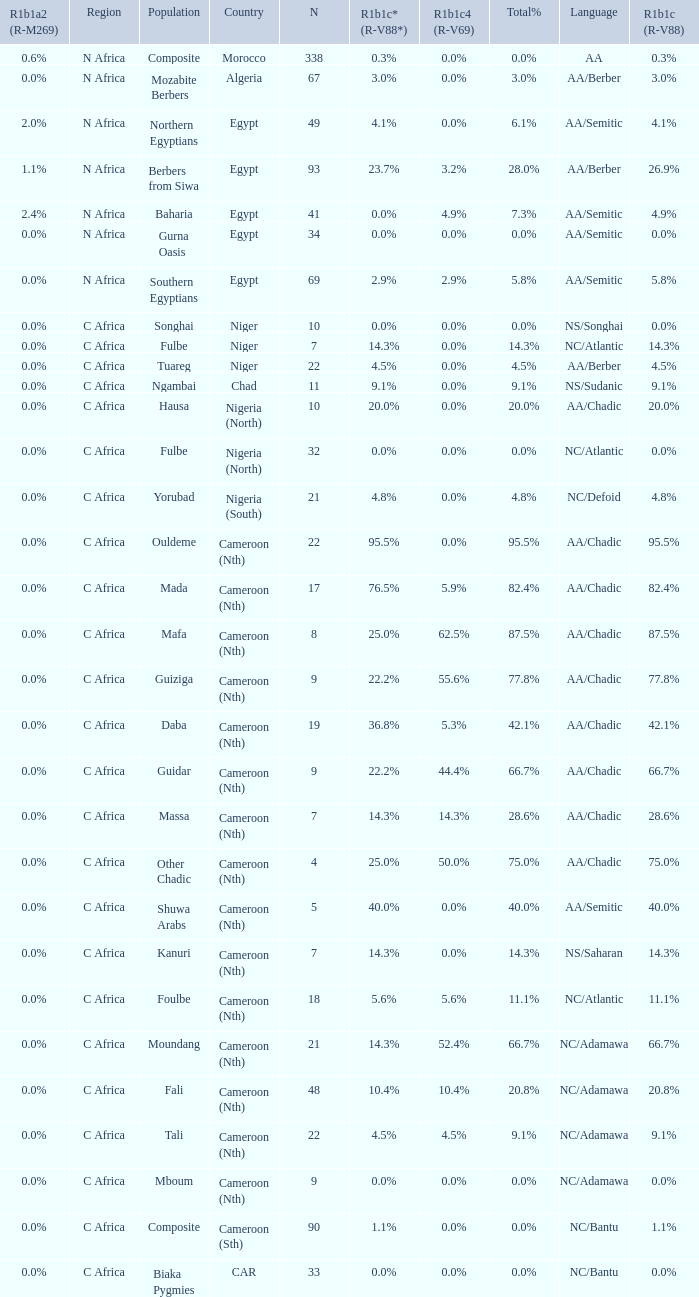6% r1b1c4 (r-v69)? 9.0. 